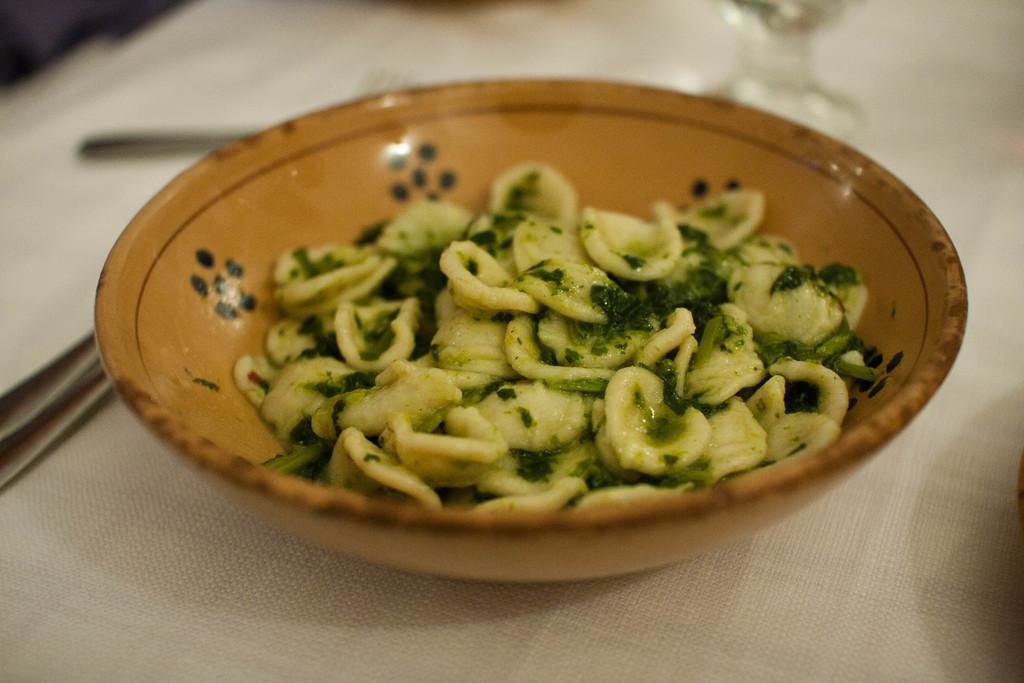What is present in the bowl in the image? There is food in the bowl in the image. Can you describe the background of the image? The background of the image is blurry. What is located at the bottom of the image? There appears to be a cloth at the bottom of the image. What type of winter produce can be seen in the image? There is no winter produce present in the image, as it only features a bowl with food and a blurry background. 